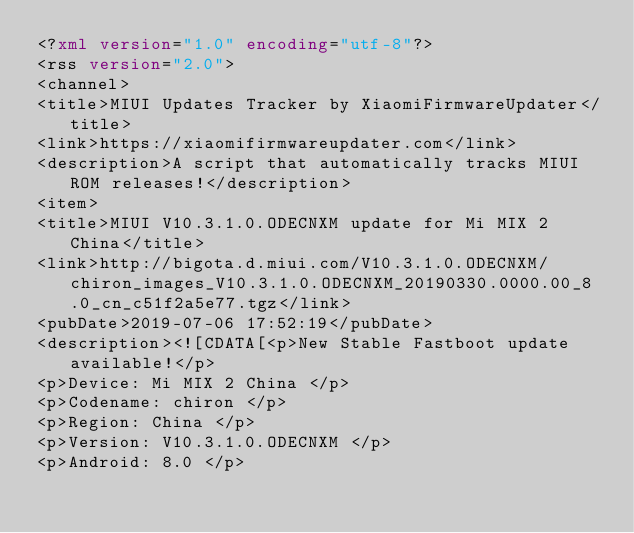<code> <loc_0><loc_0><loc_500><loc_500><_XML_><?xml version="1.0" encoding="utf-8"?>
<rss version="2.0">
<channel>
<title>MIUI Updates Tracker by XiaomiFirmwareUpdater</title>
<link>https://xiaomifirmwareupdater.com</link>
<description>A script that automatically tracks MIUI ROM releases!</description>
<item>
<title>MIUI V10.3.1.0.ODECNXM update for Mi MIX 2 China</title>
<link>http://bigota.d.miui.com/V10.3.1.0.ODECNXM/chiron_images_V10.3.1.0.ODECNXM_20190330.0000.00_8.0_cn_c51f2a5e77.tgz</link>
<pubDate>2019-07-06 17:52:19</pubDate>
<description><![CDATA[<p>New Stable Fastboot update available!</p>
<p>Device: Mi MIX 2 China </p>
<p>Codename: chiron </p>
<p>Region: China </p>
<p>Version: V10.3.1.0.ODECNXM </p>
<p>Android: 8.0 </p></code> 